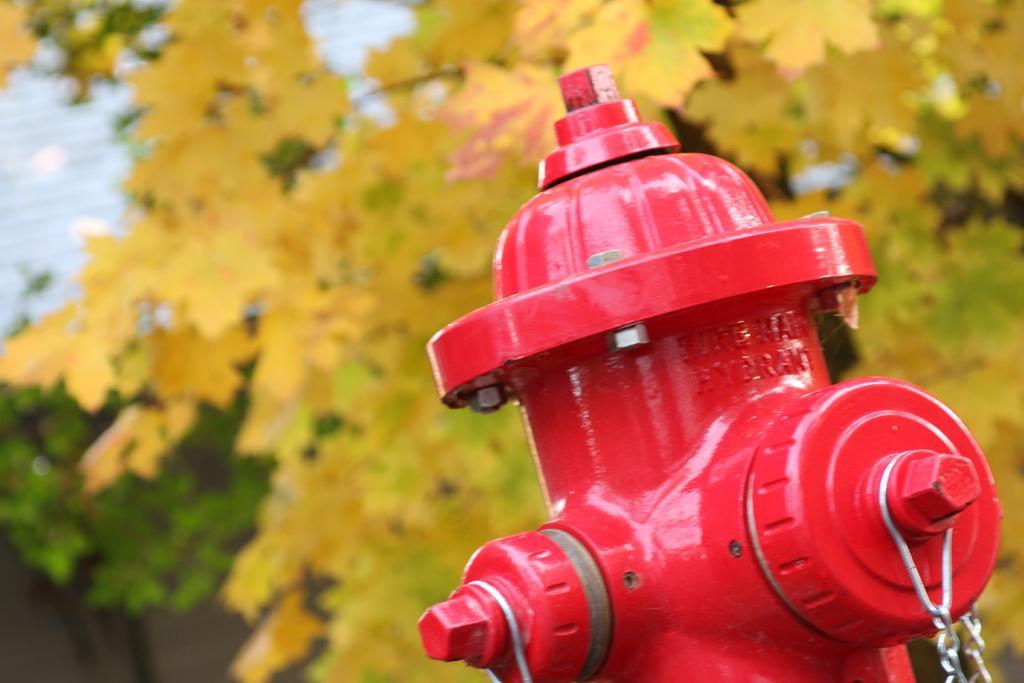How would you summarize this image in a sentence or two? In this image I can see the fire hydrant. In the background I can see few leaves in green and yellow color. 